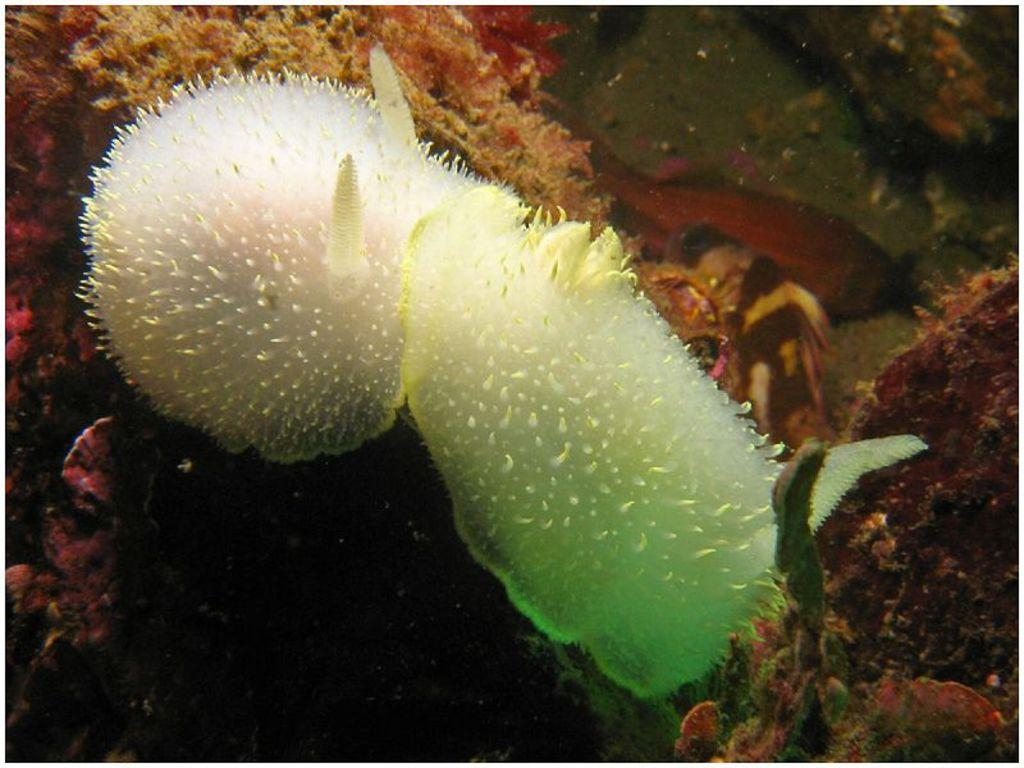What type of plants are in the image? There are submarine plants in the image. What else can be seen in the water in the image? There are species in the water in the image. Where might this image have been taken? The image might have been taken in the ocean. What is the purpose of the trucks in the image? There are no trucks present in the image, so it is not possible to determine their purpose. 